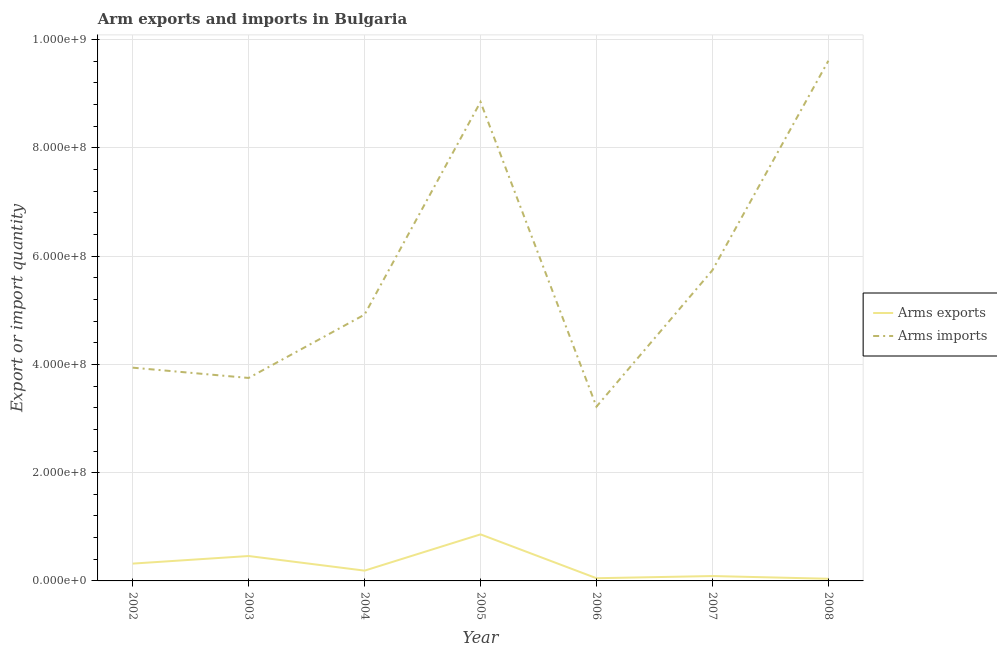Is the number of lines equal to the number of legend labels?
Offer a terse response. Yes. What is the arms exports in 2007?
Your answer should be very brief. 9.00e+06. Across all years, what is the maximum arms imports?
Your answer should be compact. 9.61e+08. Across all years, what is the minimum arms imports?
Your answer should be very brief. 3.22e+08. What is the total arms imports in the graph?
Provide a succinct answer. 4.00e+09. What is the difference between the arms exports in 2004 and that in 2007?
Ensure brevity in your answer.  1.00e+07. What is the difference between the arms imports in 2004 and the arms exports in 2005?
Provide a succinct answer. 4.06e+08. What is the average arms imports per year?
Provide a short and direct response. 5.72e+08. In the year 2006, what is the difference between the arms imports and arms exports?
Ensure brevity in your answer.  3.17e+08. In how many years, is the arms imports greater than 680000000?
Give a very brief answer. 2. What is the ratio of the arms imports in 2003 to that in 2005?
Make the answer very short. 0.42. Is the difference between the arms imports in 2003 and 2006 greater than the difference between the arms exports in 2003 and 2006?
Your response must be concise. Yes. What is the difference between the highest and the second highest arms exports?
Make the answer very short. 4.00e+07. What is the difference between the highest and the lowest arms exports?
Offer a terse response. 8.20e+07. In how many years, is the arms imports greater than the average arms imports taken over all years?
Your answer should be compact. 3. Does the arms exports monotonically increase over the years?
Offer a terse response. No. How many lines are there?
Offer a terse response. 2. How many years are there in the graph?
Your response must be concise. 7. What is the difference between two consecutive major ticks on the Y-axis?
Give a very brief answer. 2.00e+08. Are the values on the major ticks of Y-axis written in scientific E-notation?
Give a very brief answer. Yes. Where does the legend appear in the graph?
Your response must be concise. Center right. How many legend labels are there?
Offer a terse response. 2. What is the title of the graph?
Offer a very short reply. Arm exports and imports in Bulgaria. Does "Import" appear as one of the legend labels in the graph?
Make the answer very short. No. What is the label or title of the Y-axis?
Your answer should be compact. Export or import quantity. What is the Export or import quantity of Arms exports in 2002?
Provide a succinct answer. 3.20e+07. What is the Export or import quantity in Arms imports in 2002?
Your response must be concise. 3.94e+08. What is the Export or import quantity in Arms exports in 2003?
Give a very brief answer. 4.60e+07. What is the Export or import quantity of Arms imports in 2003?
Ensure brevity in your answer.  3.75e+08. What is the Export or import quantity in Arms exports in 2004?
Provide a short and direct response. 1.90e+07. What is the Export or import quantity of Arms imports in 2004?
Your answer should be compact. 4.92e+08. What is the Export or import quantity in Arms exports in 2005?
Make the answer very short. 8.60e+07. What is the Export or import quantity of Arms imports in 2005?
Offer a terse response. 8.85e+08. What is the Export or import quantity of Arms imports in 2006?
Your response must be concise. 3.22e+08. What is the Export or import quantity in Arms exports in 2007?
Your answer should be very brief. 9.00e+06. What is the Export or import quantity of Arms imports in 2007?
Your answer should be very brief. 5.74e+08. What is the Export or import quantity of Arms exports in 2008?
Provide a short and direct response. 4.00e+06. What is the Export or import quantity in Arms imports in 2008?
Offer a terse response. 9.61e+08. Across all years, what is the maximum Export or import quantity in Arms exports?
Give a very brief answer. 8.60e+07. Across all years, what is the maximum Export or import quantity of Arms imports?
Provide a short and direct response. 9.61e+08. Across all years, what is the minimum Export or import quantity of Arms exports?
Offer a terse response. 4.00e+06. Across all years, what is the minimum Export or import quantity in Arms imports?
Your answer should be compact. 3.22e+08. What is the total Export or import quantity in Arms exports in the graph?
Your answer should be compact. 2.01e+08. What is the total Export or import quantity in Arms imports in the graph?
Make the answer very short. 4.00e+09. What is the difference between the Export or import quantity of Arms exports in 2002 and that in 2003?
Offer a very short reply. -1.40e+07. What is the difference between the Export or import quantity of Arms imports in 2002 and that in 2003?
Make the answer very short. 1.90e+07. What is the difference between the Export or import quantity in Arms exports in 2002 and that in 2004?
Your answer should be compact. 1.30e+07. What is the difference between the Export or import quantity of Arms imports in 2002 and that in 2004?
Provide a short and direct response. -9.80e+07. What is the difference between the Export or import quantity in Arms exports in 2002 and that in 2005?
Ensure brevity in your answer.  -5.40e+07. What is the difference between the Export or import quantity of Arms imports in 2002 and that in 2005?
Offer a terse response. -4.91e+08. What is the difference between the Export or import quantity of Arms exports in 2002 and that in 2006?
Offer a very short reply. 2.70e+07. What is the difference between the Export or import quantity of Arms imports in 2002 and that in 2006?
Your answer should be compact. 7.20e+07. What is the difference between the Export or import quantity of Arms exports in 2002 and that in 2007?
Make the answer very short. 2.30e+07. What is the difference between the Export or import quantity of Arms imports in 2002 and that in 2007?
Your answer should be very brief. -1.80e+08. What is the difference between the Export or import quantity of Arms exports in 2002 and that in 2008?
Offer a terse response. 2.80e+07. What is the difference between the Export or import quantity in Arms imports in 2002 and that in 2008?
Offer a very short reply. -5.67e+08. What is the difference between the Export or import quantity in Arms exports in 2003 and that in 2004?
Offer a terse response. 2.70e+07. What is the difference between the Export or import quantity in Arms imports in 2003 and that in 2004?
Your answer should be very brief. -1.17e+08. What is the difference between the Export or import quantity of Arms exports in 2003 and that in 2005?
Offer a terse response. -4.00e+07. What is the difference between the Export or import quantity in Arms imports in 2003 and that in 2005?
Give a very brief answer. -5.10e+08. What is the difference between the Export or import quantity of Arms exports in 2003 and that in 2006?
Keep it short and to the point. 4.10e+07. What is the difference between the Export or import quantity of Arms imports in 2003 and that in 2006?
Ensure brevity in your answer.  5.30e+07. What is the difference between the Export or import quantity in Arms exports in 2003 and that in 2007?
Make the answer very short. 3.70e+07. What is the difference between the Export or import quantity in Arms imports in 2003 and that in 2007?
Provide a short and direct response. -1.99e+08. What is the difference between the Export or import quantity in Arms exports in 2003 and that in 2008?
Offer a very short reply. 4.20e+07. What is the difference between the Export or import quantity of Arms imports in 2003 and that in 2008?
Make the answer very short. -5.86e+08. What is the difference between the Export or import quantity of Arms exports in 2004 and that in 2005?
Offer a terse response. -6.70e+07. What is the difference between the Export or import quantity of Arms imports in 2004 and that in 2005?
Ensure brevity in your answer.  -3.93e+08. What is the difference between the Export or import quantity in Arms exports in 2004 and that in 2006?
Your response must be concise. 1.40e+07. What is the difference between the Export or import quantity in Arms imports in 2004 and that in 2006?
Your answer should be compact. 1.70e+08. What is the difference between the Export or import quantity of Arms exports in 2004 and that in 2007?
Your response must be concise. 1.00e+07. What is the difference between the Export or import quantity of Arms imports in 2004 and that in 2007?
Your response must be concise. -8.20e+07. What is the difference between the Export or import quantity in Arms exports in 2004 and that in 2008?
Offer a very short reply. 1.50e+07. What is the difference between the Export or import quantity of Arms imports in 2004 and that in 2008?
Your response must be concise. -4.69e+08. What is the difference between the Export or import quantity of Arms exports in 2005 and that in 2006?
Offer a terse response. 8.10e+07. What is the difference between the Export or import quantity in Arms imports in 2005 and that in 2006?
Make the answer very short. 5.63e+08. What is the difference between the Export or import quantity in Arms exports in 2005 and that in 2007?
Provide a succinct answer. 7.70e+07. What is the difference between the Export or import quantity in Arms imports in 2005 and that in 2007?
Your answer should be compact. 3.11e+08. What is the difference between the Export or import quantity of Arms exports in 2005 and that in 2008?
Offer a very short reply. 8.20e+07. What is the difference between the Export or import quantity of Arms imports in 2005 and that in 2008?
Your answer should be compact. -7.60e+07. What is the difference between the Export or import quantity in Arms imports in 2006 and that in 2007?
Give a very brief answer. -2.52e+08. What is the difference between the Export or import quantity in Arms exports in 2006 and that in 2008?
Offer a very short reply. 1.00e+06. What is the difference between the Export or import quantity in Arms imports in 2006 and that in 2008?
Keep it short and to the point. -6.39e+08. What is the difference between the Export or import quantity in Arms imports in 2007 and that in 2008?
Provide a short and direct response. -3.87e+08. What is the difference between the Export or import quantity of Arms exports in 2002 and the Export or import quantity of Arms imports in 2003?
Provide a short and direct response. -3.43e+08. What is the difference between the Export or import quantity of Arms exports in 2002 and the Export or import quantity of Arms imports in 2004?
Provide a succinct answer. -4.60e+08. What is the difference between the Export or import quantity of Arms exports in 2002 and the Export or import quantity of Arms imports in 2005?
Offer a terse response. -8.53e+08. What is the difference between the Export or import quantity of Arms exports in 2002 and the Export or import quantity of Arms imports in 2006?
Make the answer very short. -2.90e+08. What is the difference between the Export or import quantity in Arms exports in 2002 and the Export or import quantity in Arms imports in 2007?
Your answer should be compact. -5.42e+08. What is the difference between the Export or import quantity in Arms exports in 2002 and the Export or import quantity in Arms imports in 2008?
Your response must be concise. -9.29e+08. What is the difference between the Export or import quantity of Arms exports in 2003 and the Export or import quantity of Arms imports in 2004?
Your answer should be compact. -4.46e+08. What is the difference between the Export or import quantity of Arms exports in 2003 and the Export or import quantity of Arms imports in 2005?
Keep it short and to the point. -8.39e+08. What is the difference between the Export or import quantity in Arms exports in 2003 and the Export or import quantity in Arms imports in 2006?
Your answer should be very brief. -2.76e+08. What is the difference between the Export or import quantity of Arms exports in 2003 and the Export or import quantity of Arms imports in 2007?
Offer a very short reply. -5.28e+08. What is the difference between the Export or import quantity in Arms exports in 2003 and the Export or import quantity in Arms imports in 2008?
Offer a very short reply. -9.15e+08. What is the difference between the Export or import quantity of Arms exports in 2004 and the Export or import quantity of Arms imports in 2005?
Offer a terse response. -8.66e+08. What is the difference between the Export or import quantity of Arms exports in 2004 and the Export or import quantity of Arms imports in 2006?
Keep it short and to the point. -3.03e+08. What is the difference between the Export or import quantity in Arms exports in 2004 and the Export or import quantity in Arms imports in 2007?
Your response must be concise. -5.55e+08. What is the difference between the Export or import quantity of Arms exports in 2004 and the Export or import quantity of Arms imports in 2008?
Make the answer very short. -9.42e+08. What is the difference between the Export or import quantity of Arms exports in 2005 and the Export or import quantity of Arms imports in 2006?
Give a very brief answer. -2.36e+08. What is the difference between the Export or import quantity in Arms exports in 2005 and the Export or import quantity in Arms imports in 2007?
Your answer should be very brief. -4.88e+08. What is the difference between the Export or import quantity of Arms exports in 2005 and the Export or import quantity of Arms imports in 2008?
Keep it short and to the point. -8.75e+08. What is the difference between the Export or import quantity of Arms exports in 2006 and the Export or import quantity of Arms imports in 2007?
Keep it short and to the point. -5.69e+08. What is the difference between the Export or import quantity of Arms exports in 2006 and the Export or import quantity of Arms imports in 2008?
Offer a terse response. -9.56e+08. What is the difference between the Export or import quantity of Arms exports in 2007 and the Export or import quantity of Arms imports in 2008?
Provide a succinct answer. -9.52e+08. What is the average Export or import quantity of Arms exports per year?
Offer a terse response. 2.87e+07. What is the average Export or import quantity in Arms imports per year?
Keep it short and to the point. 5.72e+08. In the year 2002, what is the difference between the Export or import quantity in Arms exports and Export or import quantity in Arms imports?
Give a very brief answer. -3.62e+08. In the year 2003, what is the difference between the Export or import quantity in Arms exports and Export or import quantity in Arms imports?
Provide a succinct answer. -3.29e+08. In the year 2004, what is the difference between the Export or import quantity of Arms exports and Export or import quantity of Arms imports?
Offer a terse response. -4.73e+08. In the year 2005, what is the difference between the Export or import quantity of Arms exports and Export or import quantity of Arms imports?
Offer a very short reply. -7.99e+08. In the year 2006, what is the difference between the Export or import quantity in Arms exports and Export or import quantity in Arms imports?
Give a very brief answer. -3.17e+08. In the year 2007, what is the difference between the Export or import quantity of Arms exports and Export or import quantity of Arms imports?
Your response must be concise. -5.65e+08. In the year 2008, what is the difference between the Export or import quantity in Arms exports and Export or import quantity in Arms imports?
Make the answer very short. -9.57e+08. What is the ratio of the Export or import quantity in Arms exports in 2002 to that in 2003?
Your answer should be compact. 0.7. What is the ratio of the Export or import quantity of Arms imports in 2002 to that in 2003?
Your answer should be very brief. 1.05. What is the ratio of the Export or import quantity in Arms exports in 2002 to that in 2004?
Make the answer very short. 1.68. What is the ratio of the Export or import quantity of Arms imports in 2002 to that in 2004?
Provide a short and direct response. 0.8. What is the ratio of the Export or import quantity of Arms exports in 2002 to that in 2005?
Provide a short and direct response. 0.37. What is the ratio of the Export or import quantity of Arms imports in 2002 to that in 2005?
Your answer should be very brief. 0.45. What is the ratio of the Export or import quantity in Arms imports in 2002 to that in 2006?
Your answer should be compact. 1.22. What is the ratio of the Export or import quantity of Arms exports in 2002 to that in 2007?
Make the answer very short. 3.56. What is the ratio of the Export or import quantity in Arms imports in 2002 to that in 2007?
Make the answer very short. 0.69. What is the ratio of the Export or import quantity of Arms imports in 2002 to that in 2008?
Give a very brief answer. 0.41. What is the ratio of the Export or import quantity in Arms exports in 2003 to that in 2004?
Offer a terse response. 2.42. What is the ratio of the Export or import quantity of Arms imports in 2003 to that in 2004?
Your answer should be compact. 0.76. What is the ratio of the Export or import quantity of Arms exports in 2003 to that in 2005?
Your answer should be very brief. 0.53. What is the ratio of the Export or import quantity of Arms imports in 2003 to that in 2005?
Offer a terse response. 0.42. What is the ratio of the Export or import quantity in Arms imports in 2003 to that in 2006?
Provide a short and direct response. 1.16. What is the ratio of the Export or import quantity of Arms exports in 2003 to that in 2007?
Ensure brevity in your answer.  5.11. What is the ratio of the Export or import quantity of Arms imports in 2003 to that in 2007?
Your response must be concise. 0.65. What is the ratio of the Export or import quantity of Arms exports in 2003 to that in 2008?
Your answer should be compact. 11.5. What is the ratio of the Export or import quantity in Arms imports in 2003 to that in 2008?
Give a very brief answer. 0.39. What is the ratio of the Export or import quantity of Arms exports in 2004 to that in 2005?
Make the answer very short. 0.22. What is the ratio of the Export or import quantity of Arms imports in 2004 to that in 2005?
Keep it short and to the point. 0.56. What is the ratio of the Export or import quantity in Arms exports in 2004 to that in 2006?
Ensure brevity in your answer.  3.8. What is the ratio of the Export or import quantity in Arms imports in 2004 to that in 2006?
Your answer should be very brief. 1.53. What is the ratio of the Export or import quantity of Arms exports in 2004 to that in 2007?
Offer a very short reply. 2.11. What is the ratio of the Export or import quantity in Arms exports in 2004 to that in 2008?
Your answer should be compact. 4.75. What is the ratio of the Export or import quantity in Arms imports in 2004 to that in 2008?
Make the answer very short. 0.51. What is the ratio of the Export or import quantity in Arms exports in 2005 to that in 2006?
Your answer should be very brief. 17.2. What is the ratio of the Export or import quantity of Arms imports in 2005 to that in 2006?
Your answer should be very brief. 2.75. What is the ratio of the Export or import quantity of Arms exports in 2005 to that in 2007?
Provide a short and direct response. 9.56. What is the ratio of the Export or import quantity in Arms imports in 2005 to that in 2007?
Give a very brief answer. 1.54. What is the ratio of the Export or import quantity of Arms exports in 2005 to that in 2008?
Offer a terse response. 21.5. What is the ratio of the Export or import quantity of Arms imports in 2005 to that in 2008?
Your answer should be compact. 0.92. What is the ratio of the Export or import quantity in Arms exports in 2006 to that in 2007?
Offer a terse response. 0.56. What is the ratio of the Export or import quantity of Arms imports in 2006 to that in 2007?
Provide a succinct answer. 0.56. What is the ratio of the Export or import quantity in Arms exports in 2006 to that in 2008?
Your response must be concise. 1.25. What is the ratio of the Export or import quantity in Arms imports in 2006 to that in 2008?
Ensure brevity in your answer.  0.34. What is the ratio of the Export or import quantity of Arms exports in 2007 to that in 2008?
Make the answer very short. 2.25. What is the ratio of the Export or import quantity in Arms imports in 2007 to that in 2008?
Keep it short and to the point. 0.6. What is the difference between the highest and the second highest Export or import quantity of Arms exports?
Offer a very short reply. 4.00e+07. What is the difference between the highest and the second highest Export or import quantity of Arms imports?
Ensure brevity in your answer.  7.60e+07. What is the difference between the highest and the lowest Export or import quantity in Arms exports?
Ensure brevity in your answer.  8.20e+07. What is the difference between the highest and the lowest Export or import quantity in Arms imports?
Your response must be concise. 6.39e+08. 